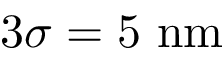Convert formula to latex. <formula><loc_0><loc_0><loc_500><loc_500>3 \sigma = 5 n m</formula> 